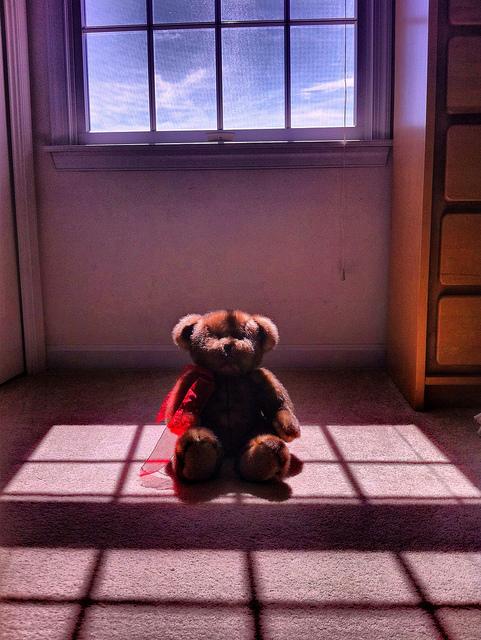What is the teddy bear sitting under?
Give a very brief answer. Window. Does this teddy bear look ominous?
Answer briefly. Yes. What is causing the light pattern on the floor?
Concise answer only. Sun. 